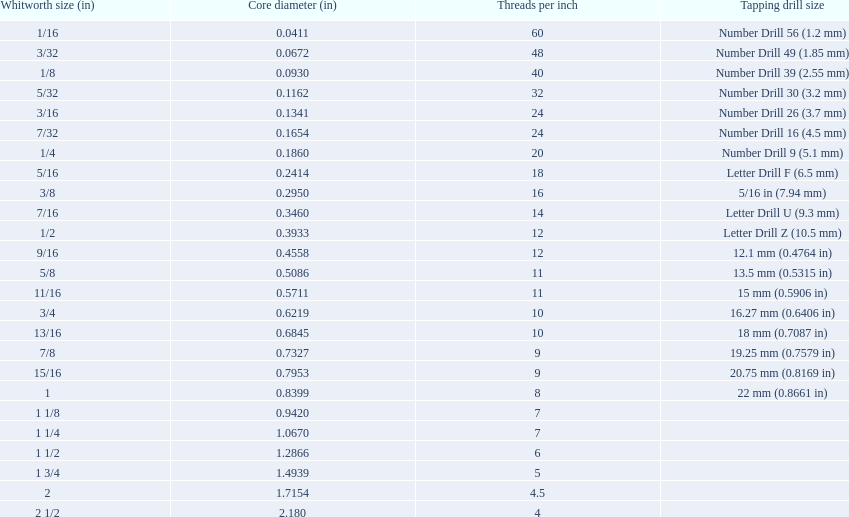A 1/16 whitworth has a core diameter of? 0.0411. Which whiteworth size has the same pitch as a 1/2? 9/16. 3/16 whiteworth has the same number of threads as? 7/32. 